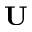Convert formula to latex. <formula><loc_0><loc_0><loc_500><loc_500>U</formula> 